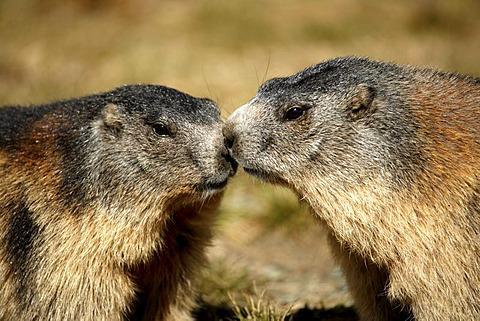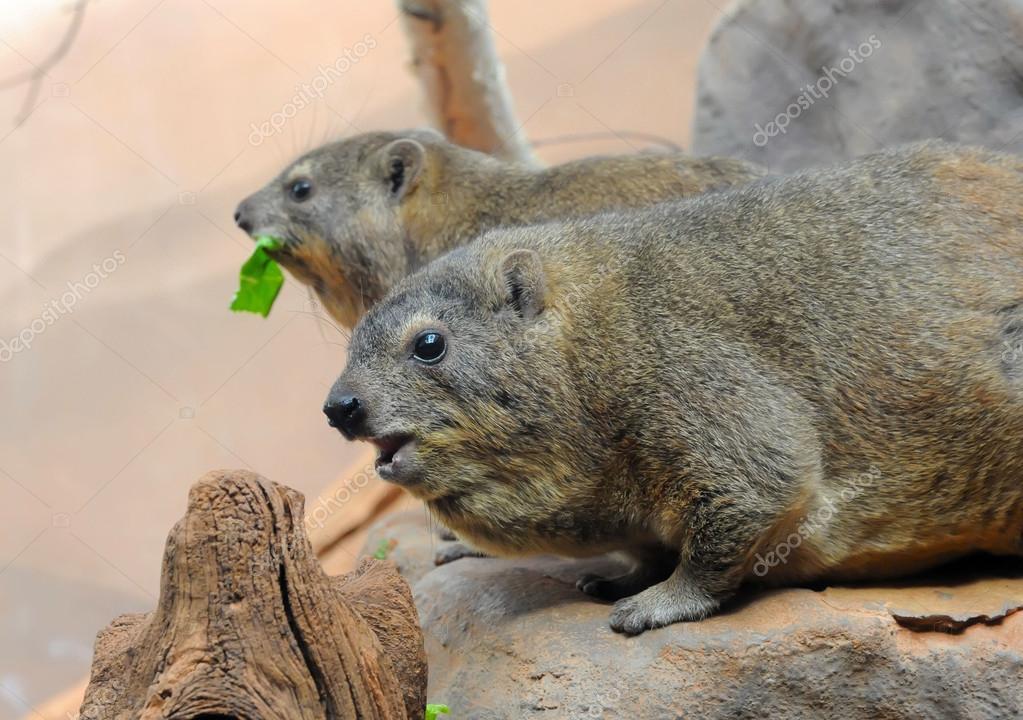The first image is the image on the left, the second image is the image on the right. For the images displayed, is the sentence "The left image contains two rodents that are face to face." factually correct? Answer yes or no. Yes. The first image is the image on the left, the second image is the image on the right. Examine the images to the left and right. Is the description "Two marmots are standing with arms around one another and noses touching, in a pose that looks like dancing." accurate? Answer yes or no. No. 